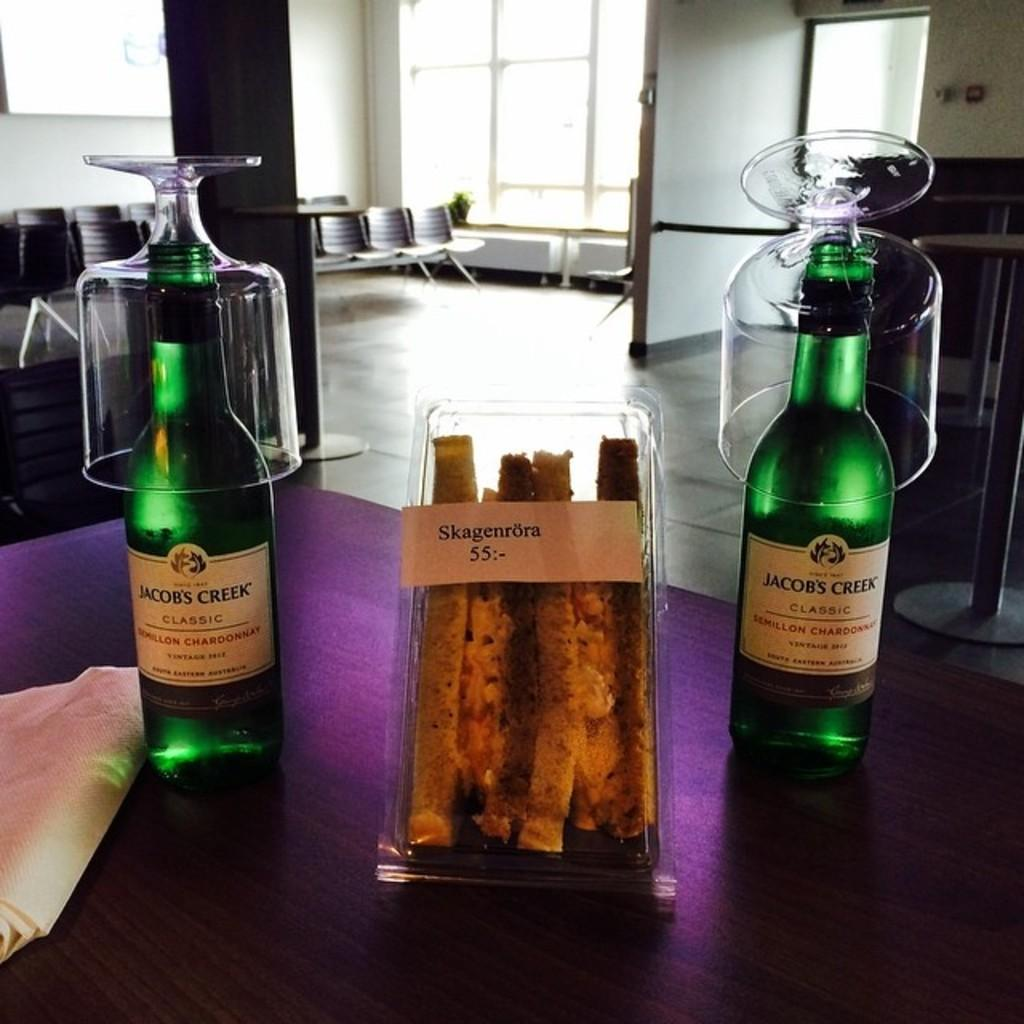<image>
Present a compact description of the photo's key features. two bottles of jacobs creek wine are sitting around a sandwich on a table 